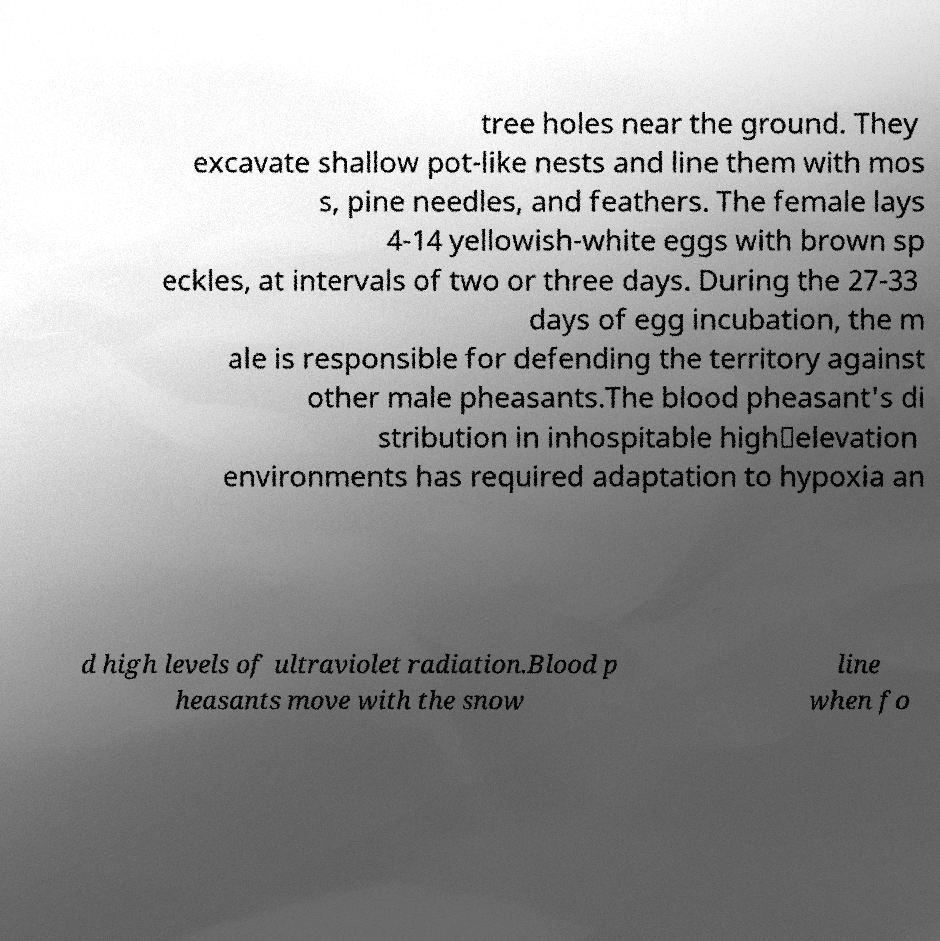For documentation purposes, I need the text within this image transcribed. Could you provide that? tree holes near the ground. They excavate shallow pot-like nests and line them with mos s, pine needles, and feathers. The female lays 4-14 yellowish-white eggs with brown sp eckles, at intervals of two or three days. During the 27-33 days of egg incubation, the m ale is responsible for defending the territory against other male pheasants.The blood pheasant's di stribution in inhospitable high‐elevation environments has required adaptation to hypoxia an d high levels of ultraviolet radiation.Blood p heasants move with the snow line when fo 